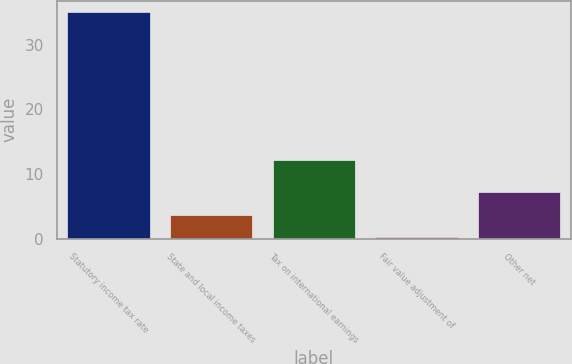Convert chart. <chart><loc_0><loc_0><loc_500><loc_500><bar_chart><fcel>Statutory income tax rate<fcel>State and local income taxes<fcel>Tax on international earnings<fcel>Fair value adjustment of<fcel>Other net<nl><fcel>35<fcel>3.68<fcel>12.2<fcel>0.2<fcel>7.16<nl></chart> 